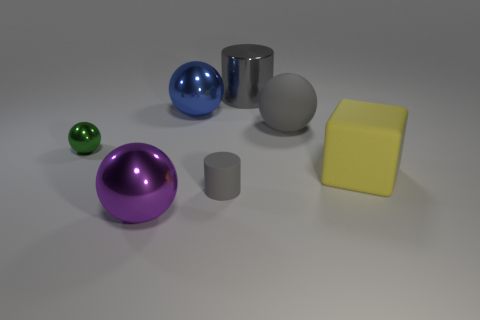There is a small object that is the same shape as the large blue shiny object; what color is it?
Provide a succinct answer. Green. Do the sphere left of the purple sphere and the gray metal thing have the same size?
Offer a terse response. No. How big is the shiny sphere in front of the gray object in front of the tiny metallic thing?
Ensure brevity in your answer.  Large. Does the small cylinder have the same material as the large gray object in front of the blue shiny thing?
Your answer should be very brief. Yes. Are there fewer small green shiny balls that are right of the big purple object than tiny gray matte objects that are on the right side of the tiny metal ball?
Keep it short and to the point. Yes. What is the color of the cube that is the same material as the tiny gray object?
Offer a very short reply. Yellow. There is a cylinder in front of the large metallic cylinder; are there any large yellow matte things that are to the left of it?
Your answer should be very brief. No. There is a metal cylinder that is the same size as the matte sphere; what color is it?
Provide a succinct answer. Gray. What number of objects are big blue spheres or big spheres?
Offer a terse response. 3. How big is the cylinder that is in front of the tiny object on the left side of the metal object in front of the tiny matte cylinder?
Give a very brief answer. Small. 